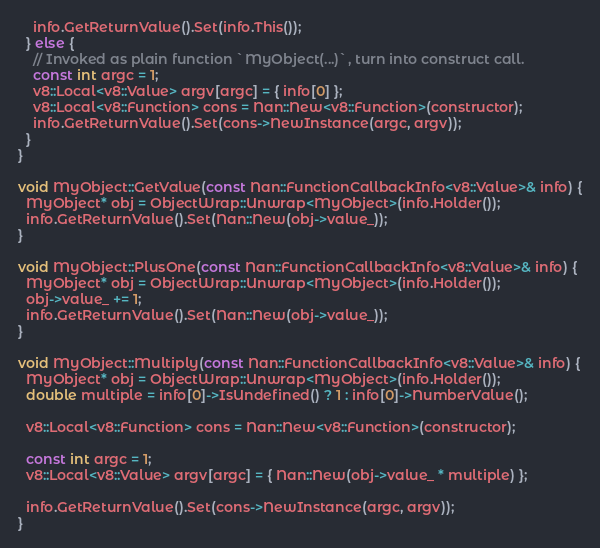<code> <loc_0><loc_0><loc_500><loc_500><_C++_>    info.GetReturnValue().Set(info.This());
  } else {
    // Invoked as plain function `MyObject(...)`, turn into construct call.
    const int argc = 1;
    v8::Local<v8::Value> argv[argc] = { info[0] };
    v8::Local<v8::Function> cons = Nan::New<v8::Function>(constructor);
    info.GetReturnValue().Set(cons->NewInstance(argc, argv));
  }
}

void MyObject::GetValue(const Nan::FunctionCallbackInfo<v8::Value>& info) {
  MyObject* obj = ObjectWrap::Unwrap<MyObject>(info.Holder());
  info.GetReturnValue().Set(Nan::New(obj->value_));
}

void MyObject::PlusOne(const Nan::FunctionCallbackInfo<v8::Value>& info) {
  MyObject* obj = ObjectWrap::Unwrap<MyObject>(info.Holder());
  obj->value_ += 1;
  info.GetReturnValue().Set(Nan::New(obj->value_));
}

void MyObject::Multiply(const Nan::FunctionCallbackInfo<v8::Value>& info) {
  MyObject* obj = ObjectWrap::Unwrap<MyObject>(info.Holder());
  double multiple = info[0]->IsUndefined() ? 1 : info[0]->NumberValue();

  v8::Local<v8::Function> cons = Nan::New<v8::Function>(constructor);

  const int argc = 1;
  v8::Local<v8::Value> argv[argc] = { Nan::New(obj->value_ * multiple) };

  info.GetReturnValue().Set(cons->NewInstance(argc, argv));
}
</code> 